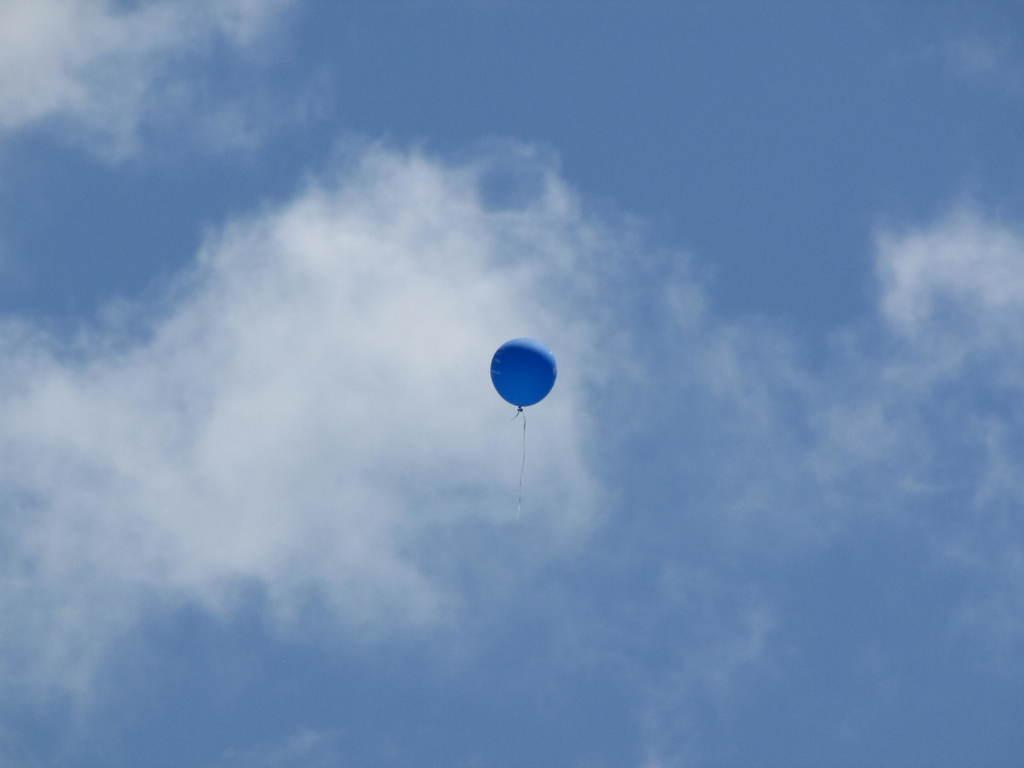What color is the balloon in the image? The balloon in the image is blue. Where is the balloon located in the image? The balloon is in the air. What can be seen in the sky in the image? Clouds and the sky are visible in the image. Can you tell me how many mailboxes are visible in the image? There are no mailboxes present in the image; it features a blue balloon in the air and clouds in the sky. What force is responsible for keeping the balloon in the air in the image? The image does not provide information about the force keeping the balloon in the air, but in reality, it would be the buoyant force of the helium inside the balloon. 